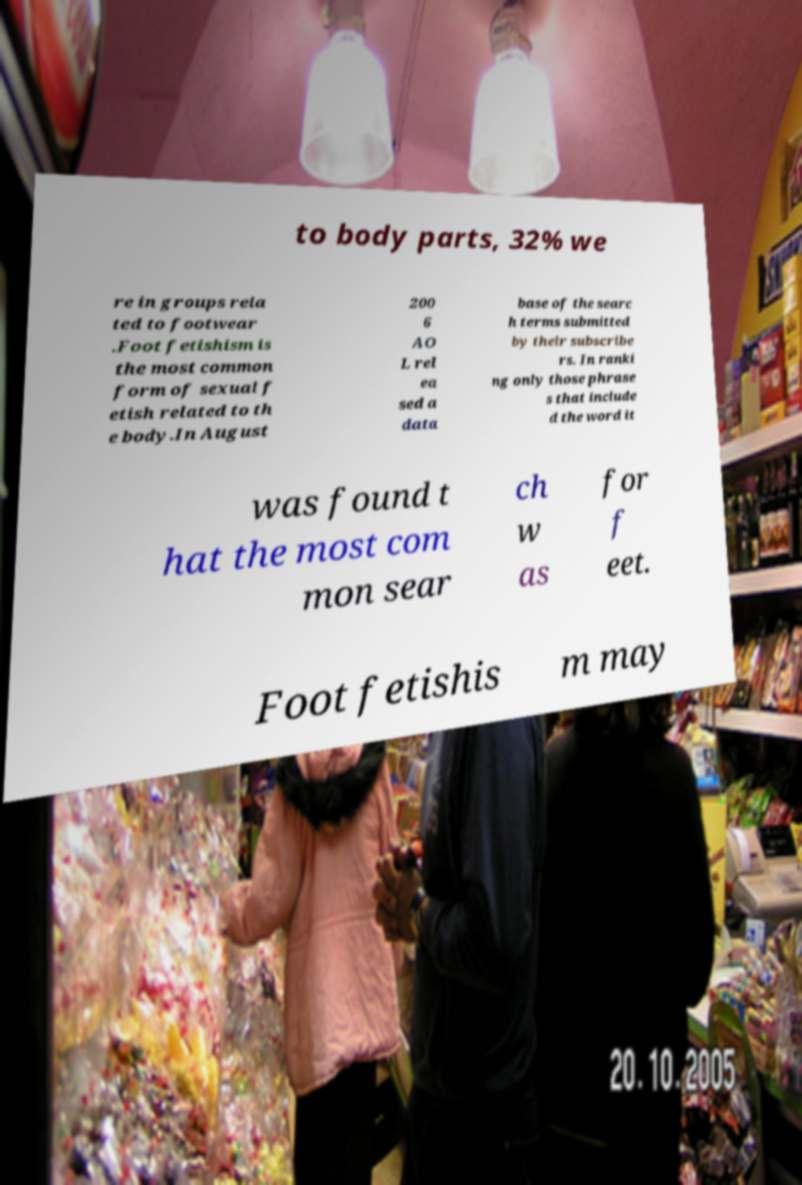There's text embedded in this image that I need extracted. Can you transcribe it verbatim? to body parts, 32% we re in groups rela ted to footwear .Foot fetishism is the most common form of sexual f etish related to th e body.In August 200 6 AO L rel ea sed a data base of the searc h terms submitted by their subscribe rs. In ranki ng only those phrase s that include d the word it was found t hat the most com mon sear ch w as for f eet. Foot fetishis m may 